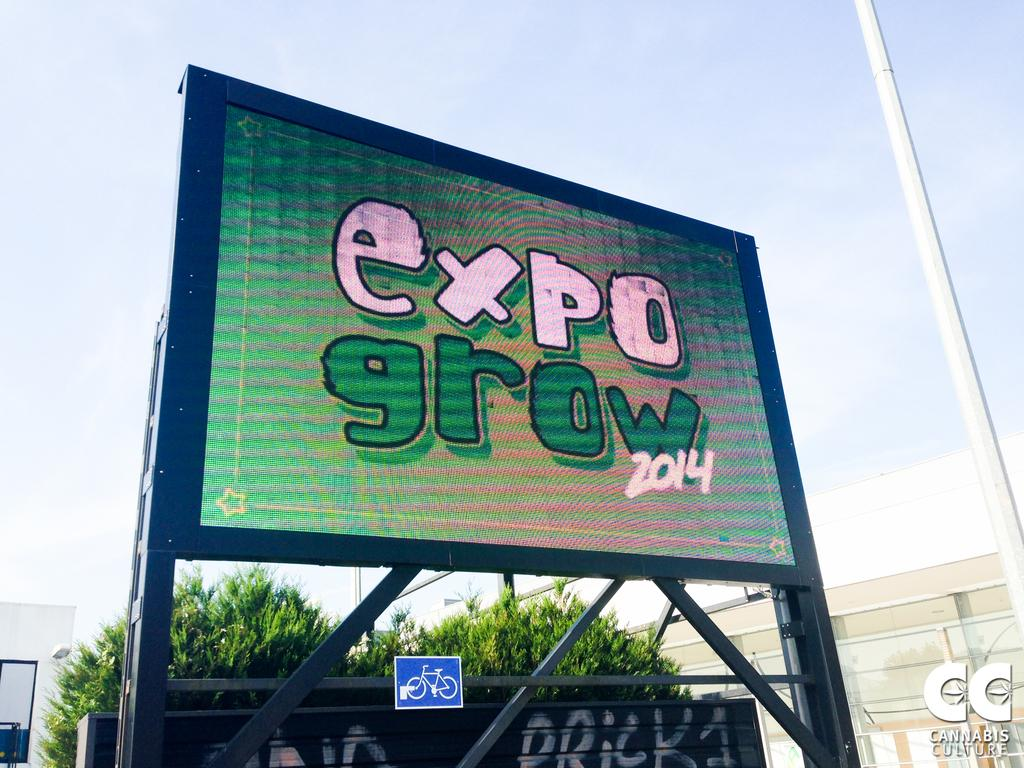Provide a one-sentence caption for the provided image. An electronic board is outdoors, the board reads "expo growth" in pink and green letters. 